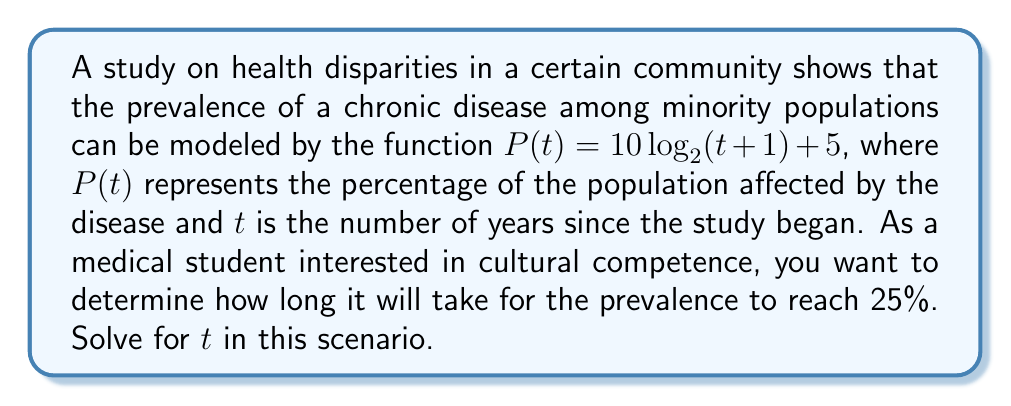What is the answer to this math problem? Let's approach this step-by-step:

1) We start with the equation: $P(t) = 10 \log_2(t+1) + 5$

2) We want to find $t$ when $P(t) = 25$. So, let's substitute this:

   $25 = 10 \log_2(t+1) + 5$

3) Subtract 5 from both sides:

   $20 = 10 \log_2(t+1)$

4) Divide both sides by 10:

   $2 = \log_2(t+1)$

5) Now, we need to solve for $t$. We can do this by applying $2^x$ to both sides:

   $2^2 = 2^{\log_2(t+1)}$

6) The left side simplifies to 4, and the right side simplifies to $t+1$:

   $4 = t+1$

7) Finally, subtract 1 from both sides:

   $3 = t$

Therefore, it will take 3 years for the prevalence to reach 25%.
Answer: 3 years 